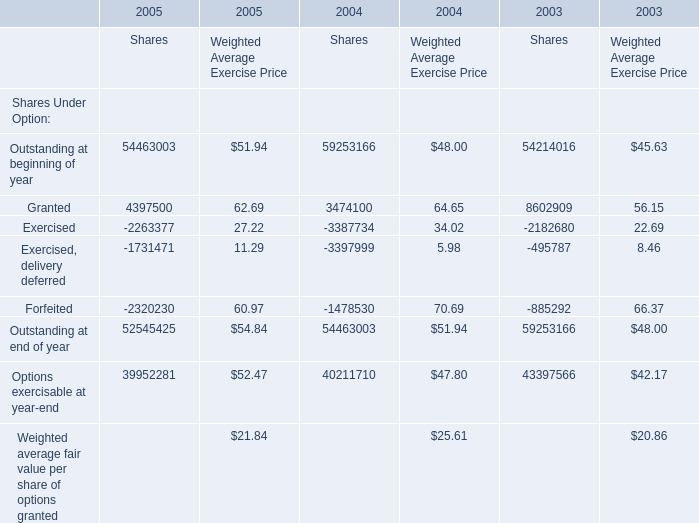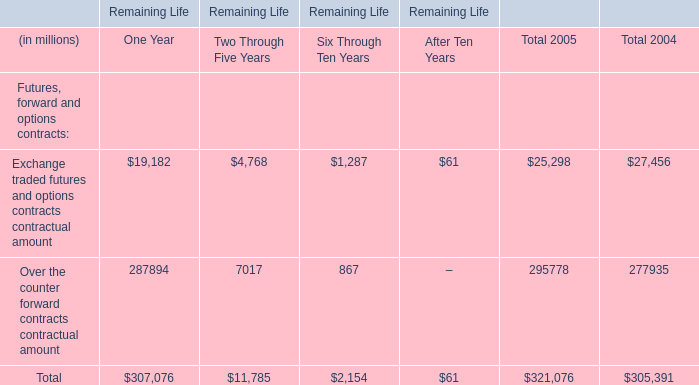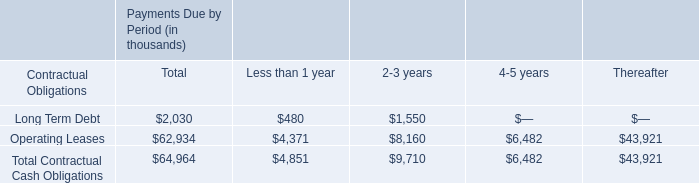What will granted for Shares reach in 2006 if it continues to grow at its current rate? 
Computations: (4397500 * (1 + ((4397500 - 3474100) / 3474100)))
Answer: 5566335.52575. 